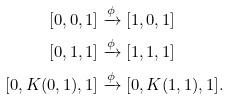Convert formula to latex. <formula><loc_0><loc_0><loc_500><loc_500>[ 0 , 0 , 1 ] & \xrightarrow { \phi } [ 1 , 0 , 1 ] \\ [ 0 , 1 , 1 ] & \xrightarrow { \phi } [ 1 , 1 , 1 ] \\ [ 0 , K ( 0 , 1 ) , 1 ] & \xrightarrow { \phi } [ 0 , K ( 1 , 1 ) , 1 ] .</formula> 